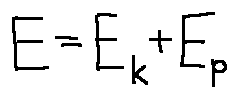Convert formula to latex. <formula><loc_0><loc_0><loc_500><loc_500>E = E _ { k } + E _ { p }</formula> 